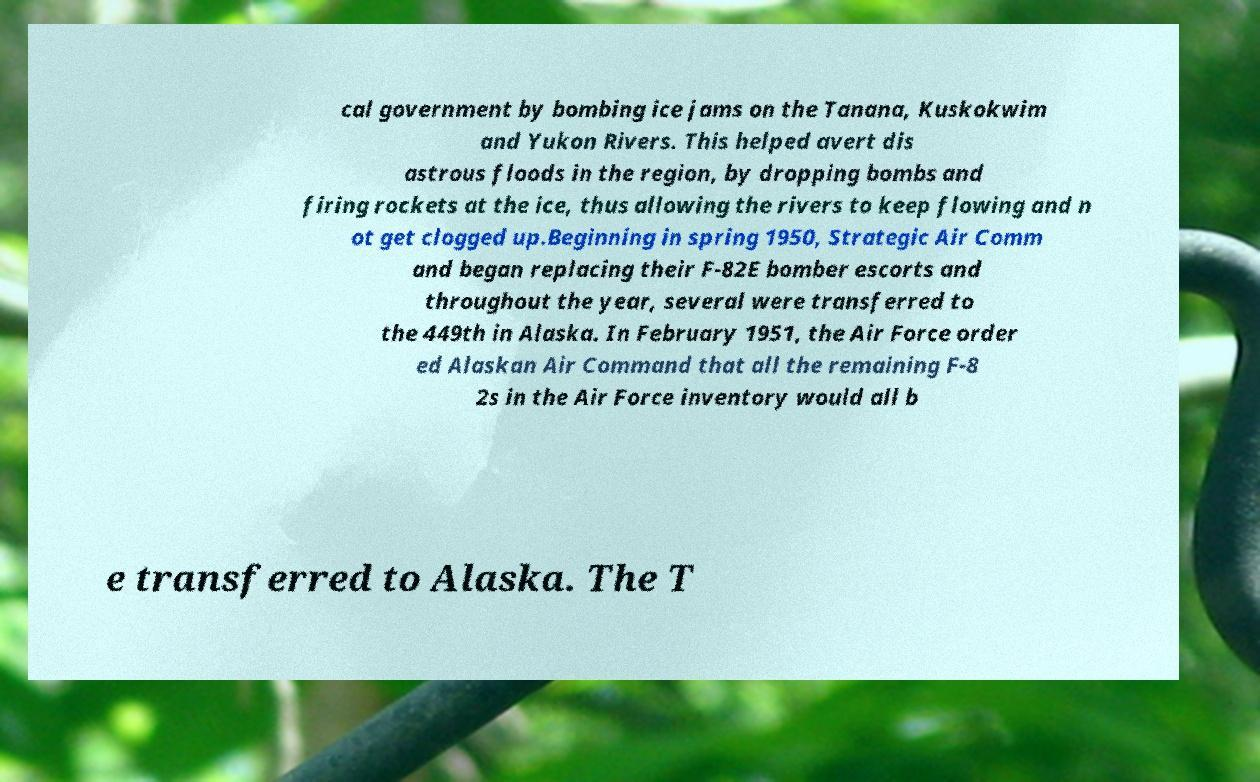Can you accurately transcribe the text from the provided image for me? cal government by bombing ice jams on the Tanana, Kuskokwim and Yukon Rivers. This helped avert dis astrous floods in the region, by dropping bombs and firing rockets at the ice, thus allowing the rivers to keep flowing and n ot get clogged up.Beginning in spring 1950, Strategic Air Comm and began replacing their F-82E bomber escorts and throughout the year, several were transferred to the 449th in Alaska. In February 1951, the Air Force order ed Alaskan Air Command that all the remaining F-8 2s in the Air Force inventory would all b e transferred to Alaska. The T 